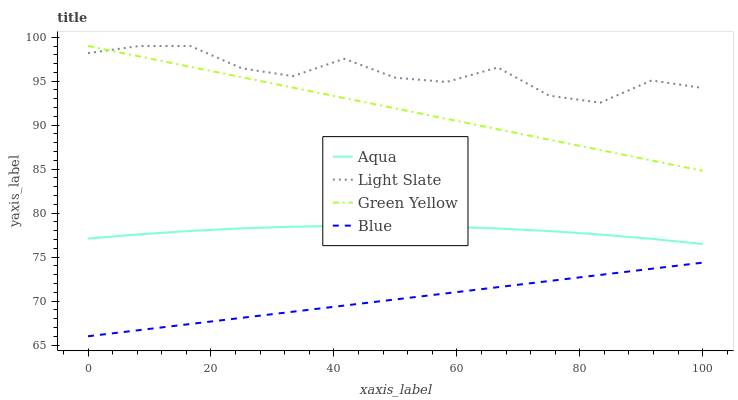Does Blue have the minimum area under the curve?
Answer yes or no. Yes. Does Green Yellow have the minimum area under the curve?
Answer yes or no. No. Does Green Yellow have the maximum area under the curve?
Answer yes or no. No. Is Light Slate the roughest?
Answer yes or no. Yes. Is Green Yellow the smoothest?
Answer yes or no. No. Is Green Yellow the roughest?
Answer yes or no. No. Does Green Yellow have the lowest value?
Answer yes or no. No. Does Blue have the highest value?
Answer yes or no. No. Is Aqua less than Green Yellow?
Answer yes or no. Yes. Is Green Yellow greater than Blue?
Answer yes or no. Yes. Does Aqua intersect Green Yellow?
Answer yes or no. No. 